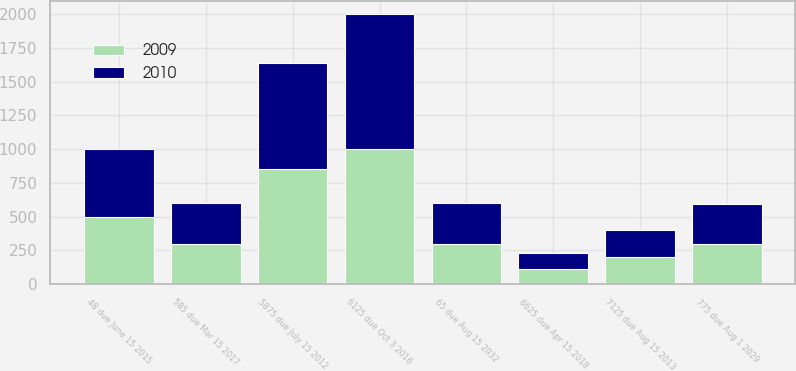<chart> <loc_0><loc_0><loc_500><loc_500><stacked_bar_chart><ecel><fcel>5875 due July 15 2012<fcel>7125 due Aug 15 2013<fcel>48 due June 15 2015<fcel>6125 due Oct 3 2016<fcel>585 due Mar 15 2017<fcel>6625 due Apr 15 2018<fcel>775 due Aug 1 2029<fcel>65 due Aug 15 2032<nl><fcel>2010<fcel>791<fcel>200<fcel>500<fcel>1000<fcel>300<fcel>114<fcel>296<fcel>300<nl><fcel>2009<fcel>850<fcel>200<fcel>500<fcel>1000<fcel>300<fcel>114<fcel>296<fcel>300<nl></chart> 